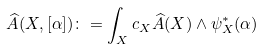Convert formula to latex. <formula><loc_0><loc_0><loc_500><loc_500>\widehat { A } ( X , [ \alpha ] ) \colon = \int _ { X } c _ { X } \widehat { A } ( X ) \wedge \psi _ { X } ^ { * } ( \alpha )</formula> 